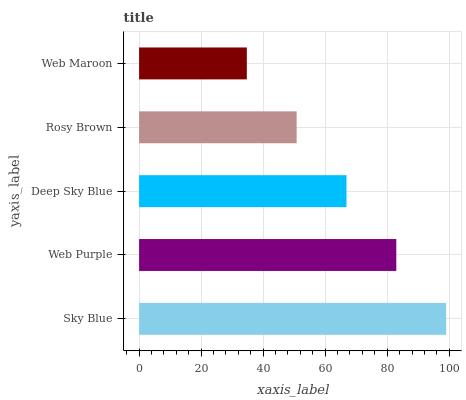Is Web Maroon the minimum?
Answer yes or no. Yes. Is Sky Blue the maximum?
Answer yes or no. Yes. Is Web Purple the minimum?
Answer yes or no. No. Is Web Purple the maximum?
Answer yes or no. No. Is Sky Blue greater than Web Purple?
Answer yes or no. Yes. Is Web Purple less than Sky Blue?
Answer yes or no. Yes. Is Web Purple greater than Sky Blue?
Answer yes or no. No. Is Sky Blue less than Web Purple?
Answer yes or no. No. Is Deep Sky Blue the high median?
Answer yes or no. Yes. Is Deep Sky Blue the low median?
Answer yes or no. Yes. Is Web Maroon the high median?
Answer yes or no. No. Is Rosy Brown the low median?
Answer yes or no. No. 